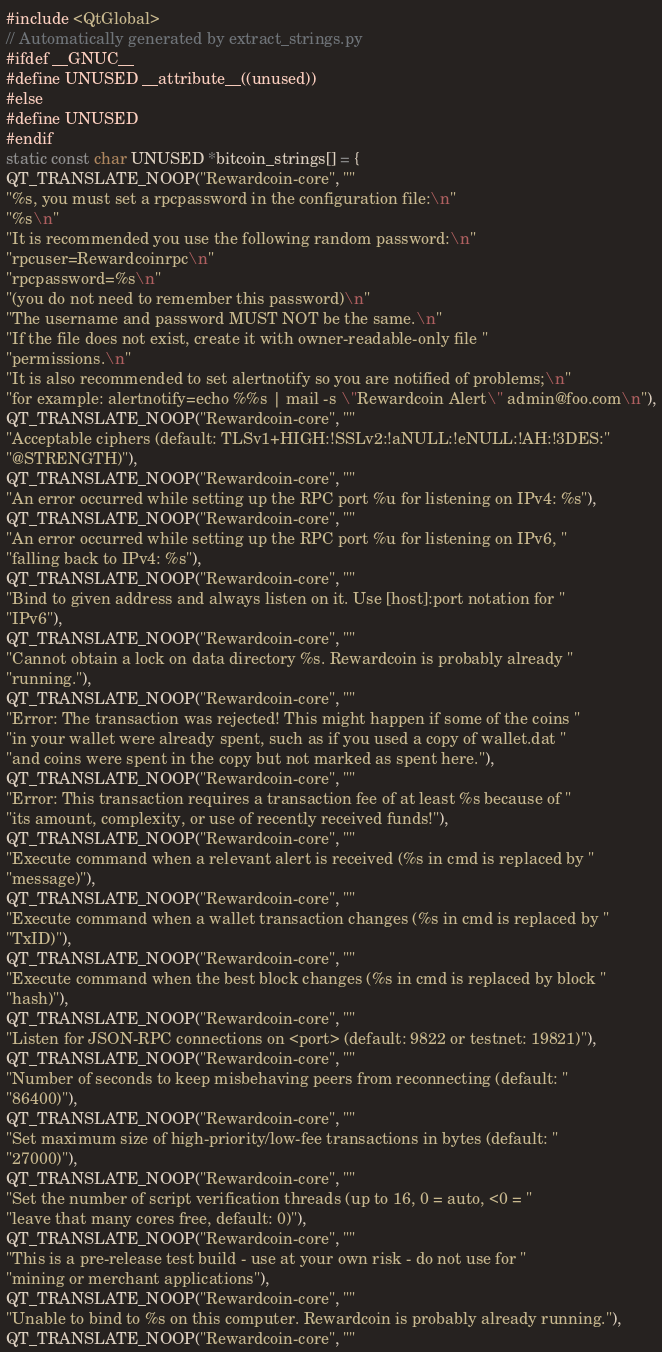<code> <loc_0><loc_0><loc_500><loc_500><_C++_>#include <QtGlobal>
// Automatically generated by extract_strings.py
#ifdef __GNUC__
#define UNUSED __attribute__((unused))
#else
#define UNUSED
#endif
static const char UNUSED *bitcoin_strings[] = {
QT_TRANSLATE_NOOP("Rewardcoin-core", ""
"%s, you must set a rpcpassword in the configuration file:\n"
"%s\n"
"It is recommended you use the following random password:\n"
"rpcuser=Rewardcoinrpc\n"
"rpcpassword=%s\n"
"(you do not need to remember this password)\n"
"The username and password MUST NOT be the same.\n"
"If the file does not exist, create it with owner-readable-only file "
"permissions.\n"
"It is also recommended to set alertnotify so you are notified of problems;\n"
"for example: alertnotify=echo %%s | mail -s \"Rewardcoin Alert\" admin@foo.com\n"),
QT_TRANSLATE_NOOP("Rewardcoin-core", ""
"Acceptable ciphers (default: TLSv1+HIGH:!SSLv2:!aNULL:!eNULL:!AH:!3DES:"
"@STRENGTH)"),
QT_TRANSLATE_NOOP("Rewardcoin-core", ""
"An error occurred while setting up the RPC port %u for listening on IPv4: %s"),
QT_TRANSLATE_NOOP("Rewardcoin-core", ""
"An error occurred while setting up the RPC port %u for listening on IPv6, "
"falling back to IPv4: %s"),
QT_TRANSLATE_NOOP("Rewardcoin-core", ""
"Bind to given address and always listen on it. Use [host]:port notation for "
"IPv6"),
QT_TRANSLATE_NOOP("Rewardcoin-core", ""
"Cannot obtain a lock on data directory %s. Rewardcoin is probably already "
"running."),
QT_TRANSLATE_NOOP("Rewardcoin-core", ""
"Error: The transaction was rejected! This might happen if some of the coins "
"in your wallet were already spent, such as if you used a copy of wallet.dat "
"and coins were spent in the copy but not marked as spent here."),
QT_TRANSLATE_NOOP("Rewardcoin-core", ""
"Error: This transaction requires a transaction fee of at least %s because of "
"its amount, complexity, or use of recently received funds!"),
QT_TRANSLATE_NOOP("Rewardcoin-core", ""
"Execute command when a relevant alert is received (%s in cmd is replaced by "
"message)"),
QT_TRANSLATE_NOOP("Rewardcoin-core", ""
"Execute command when a wallet transaction changes (%s in cmd is replaced by "
"TxID)"),
QT_TRANSLATE_NOOP("Rewardcoin-core", ""
"Execute command when the best block changes (%s in cmd is replaced by block "
"hash)"),
QT_TRANSLATE_NOOP("Rewardcoin-core", ""
"Listen for JSON-RPC connections on <port> (default: 9822 or testnet: 19821)"),
QT_TRANSLATE_NOOP("Rewardcoin-core", ""
"Number of seconds to keep misbehaving peers from reconnecting (default: "
"86400)"),
QT_TRANSLATE_NOOP("Rewardcoin-core", ""
"Set maximum size of high-priority/low-fee transactions in bytes (default: "
"27000)"),
QT_TRANSLATE_NOOP("Rewardcoin-core", ""
"Set the number of script verification threads (up to 16, 0 = auto, <0 = "
"leave that many cores free, default: 0)"),
QT_TRANSLATE_NOOP("Rewardcoin-core", ""
"This is a pre-release test build - use at your own risk - do not use for "
"mining or merchant applications"),
QT_TRANSLATE_NOOP("Rewardcoin-core", ""
"Unable to bind to %s on this computer. Rewardcoin is probably already running."),
QT_TRANSLATE_NOOP("Rewardcoin-core", ""</code> 